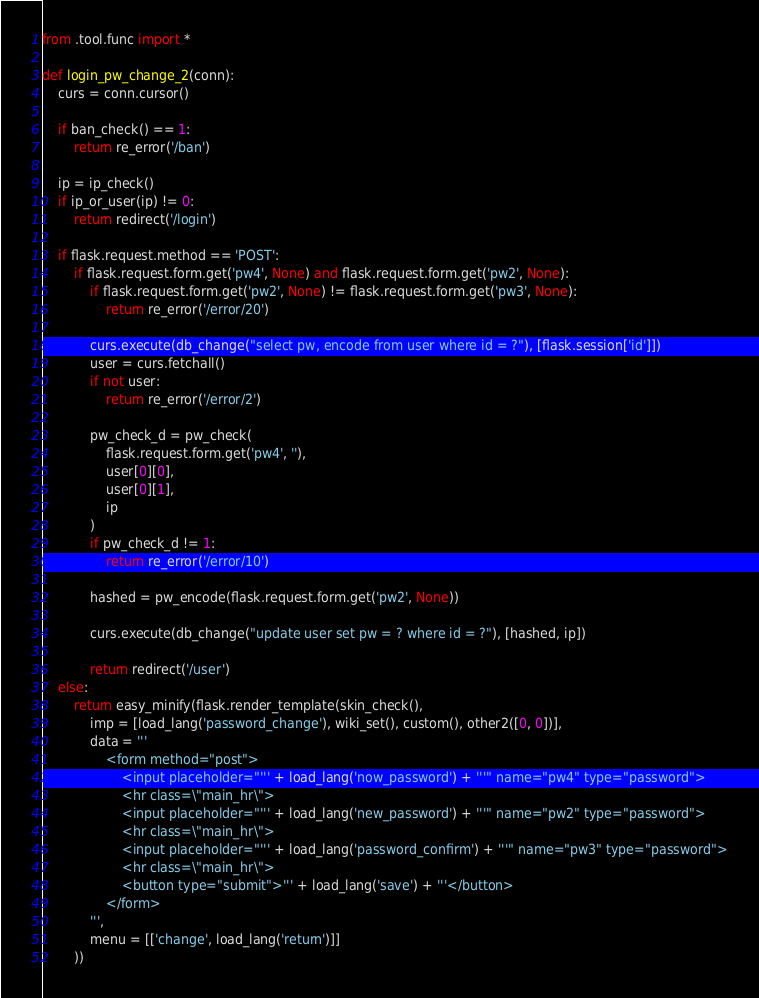<code> <loc_0><loc_0><loc_500><loc_500><_Python_>from .tool.func import *

def login_pw_change_2(conn):
    curs = conn.cursor()
    
    if ban_check() == 1:
        return re_error('/ban')

    ip = ip_check()
    if ip_or_user(ip) != 0:
        return redirect('/login')

    if flask.request.method == 'POST':
        if flask.request.form.get('pw4', None) and flask.request.form.get('pw2', None):
            if flask.request.form.get('pw2', None) != flask.request.form.get('pw3', None):
                return re_error('/error/20')

            curs.execute(db_change("select pw, encode from user where id = ?"), [flask.session['id']])
            user = curs.fetchall()
            if not user:
                return re_error('/error/2')
               
            pw_check_d = pw_check(
                flask.request.form.get('pw4', ''), 
                user[0][0],
                user[0][1],
                ip
            )
            if pw_check_d != 1:
                return re_error('/error/10')

            hashed = pw_encode(flask.request.form.get('pw2', None))
                
            curs.execute(db_change("update user set pw = ? where id = ?"), [hashed, ip])

            return redirect('/user')
    else:
        return easy_minify(flask.render_template(skin_check(), 
            imp = [load_lang('password_change'), wiki_set(), custom(), other2([0, 0])],
            data = '''
                <form method="post">
                    <input placeholder="''' + load_lang('now_password') + '''" name="pw4" type="password">
                    <hr class=\"main_hr\">
                    <input placeholder="''' + load_lang('new_password') + '''" name="pw2" type="password">
                    <hr class=\"main_hr\">
                    <input placeholder="''' + load_lang('password_confirm') + '''" name="pw3" type="password">
                    <hr class=\"main_hr\">
                    <button type="submit">''' + load_lang('save') + '''</button>
                </form>
            ''',
            menu = [['change', load_lang('return')]]
        ))</code> 